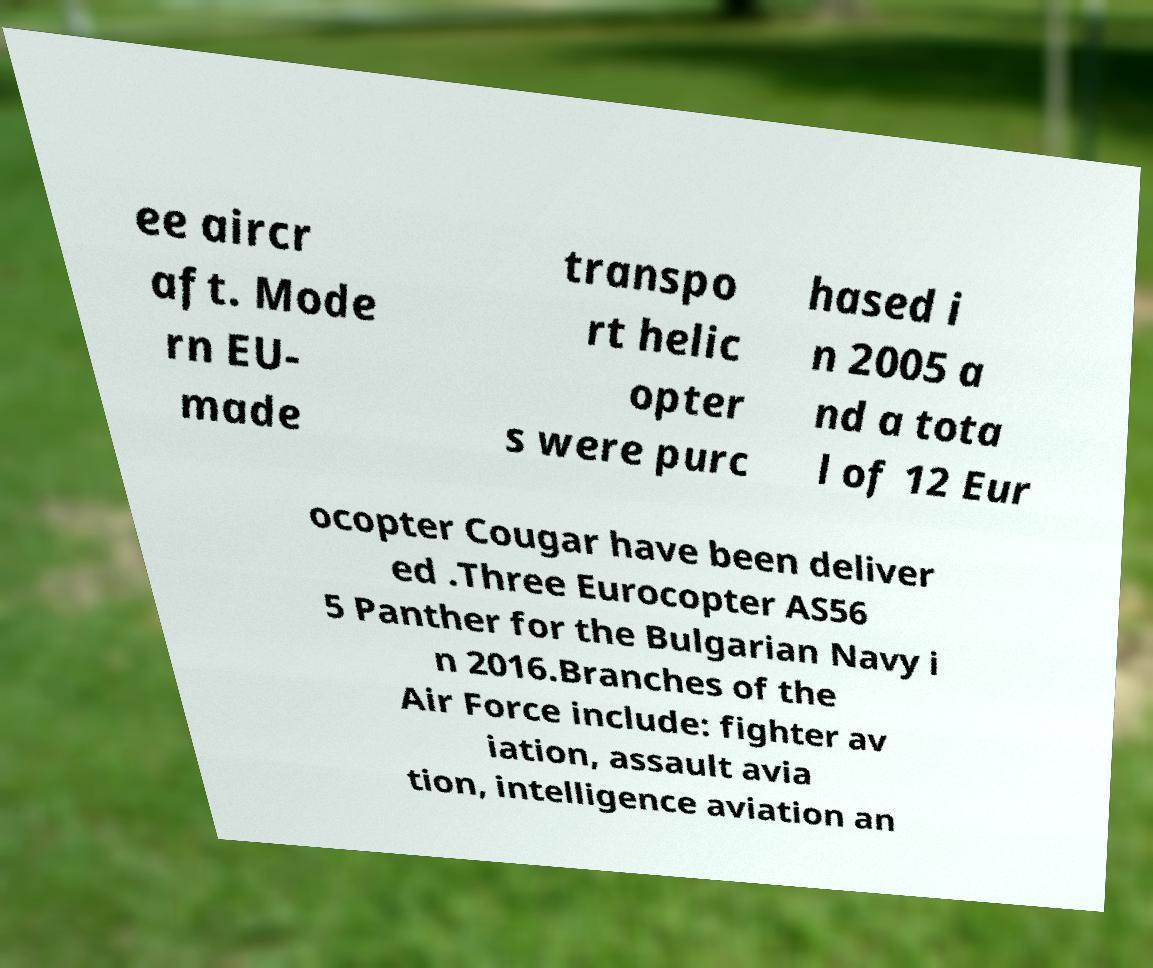Could you assist in decoding the text presented in this image and type it out clearly? ee aircr aft. Mode rn EU- made transpo rt helic opter s were purc hased i n 2005 a nd a tota l of 12 Eur ocopter Cougar have been deliver ed .Three Eurocopter AS56 5 Panther for the Bulgarian Navy i n 2016.Branches of the Air Force include: fighter av iation, assault avia tion, intelligence aviation an 